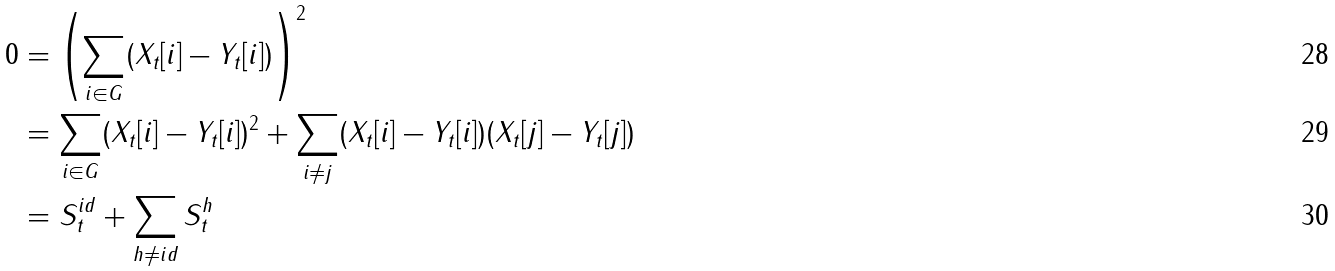Convert formula to latex. <formula><loc_0><loc_0><loc_500><loc_500>0 & = \left ( \sum _ { i \in G } ( X _ { t } [ i ] - Y _ { t } [ i ] ) \right ) ^ { 2 } \\ & = \sum _ { i \in G } ( X _ { t } [ i ] - Y _ { t } [ i ] ) ^ { 2 } + \sum _ { i \ne j } ( X _ { t } [ i ] - Y _ { t } [ i ] ) ( X _ { t } [ j ] - Y _ { t } [ j ] ) \\ & = S _ { t } ^ { i d } + \sum _ { h \ne i d } S _ { t } ^ { h }</formula> 